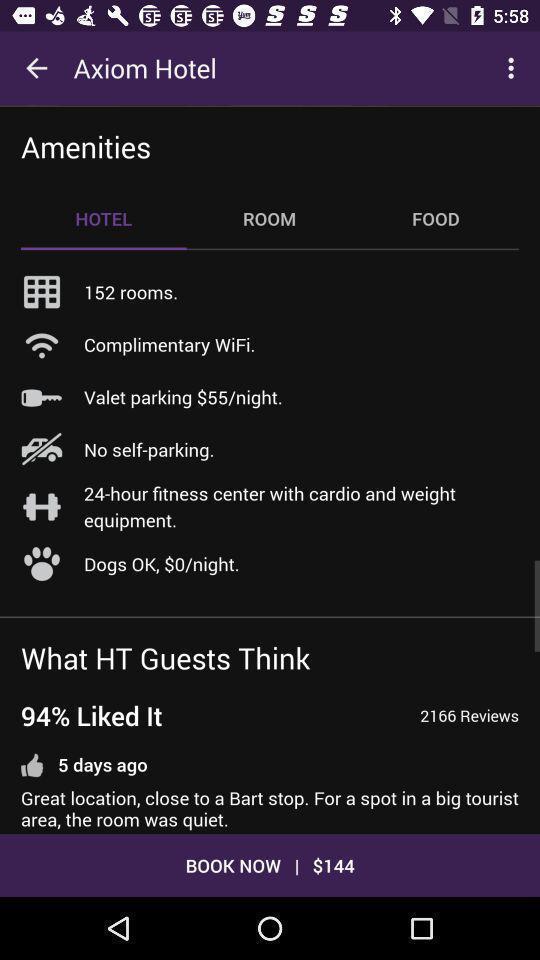Tell me what you see in this picture. Page of a hotel app showing services and other options. 